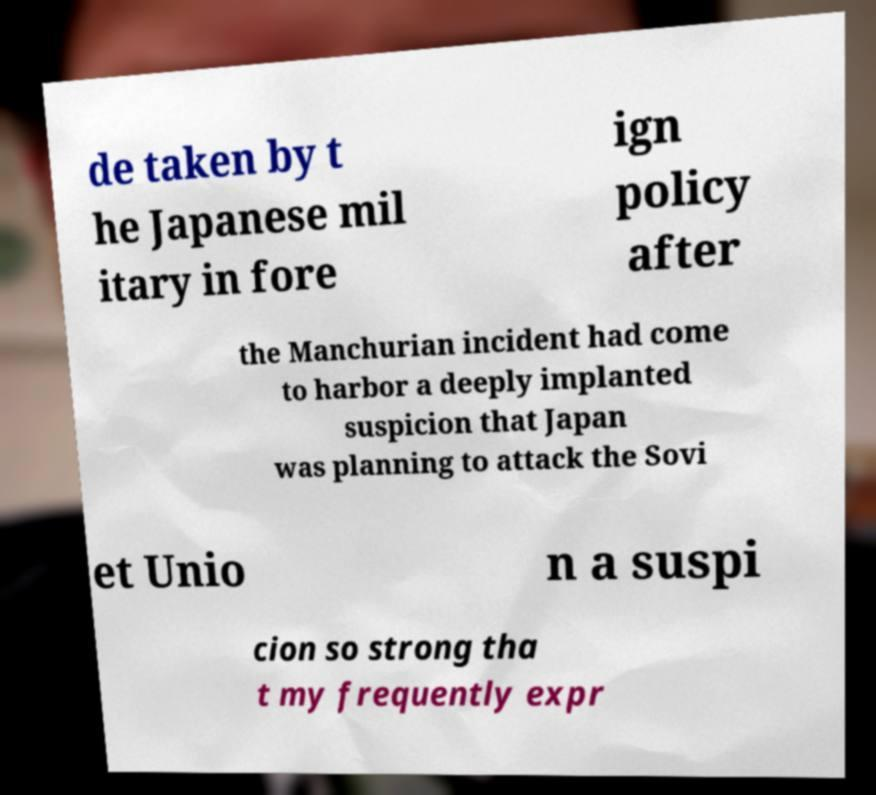Can you read and provide the text displayed in the image?This photo seems to have some interesting text. Can you extract and type it out for me? de taken by t he Japanese mil itary in fore ign policy after the Manchurian incident had come to harbor a deeply implanted suspicion that Japan was planning to attack the Sovi et Unio n a suspi cion so strong tha t my frequently expr 